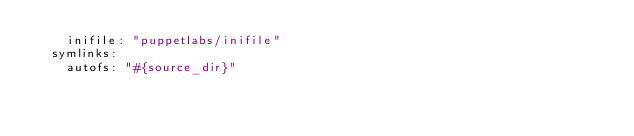<code> <loc_0><loc_0><loc_500><loc_500><_YAML_>    inifile: "puppetlabs/inifile"
  symlinks:
    autofs: "#{source_dir}"
</code> 